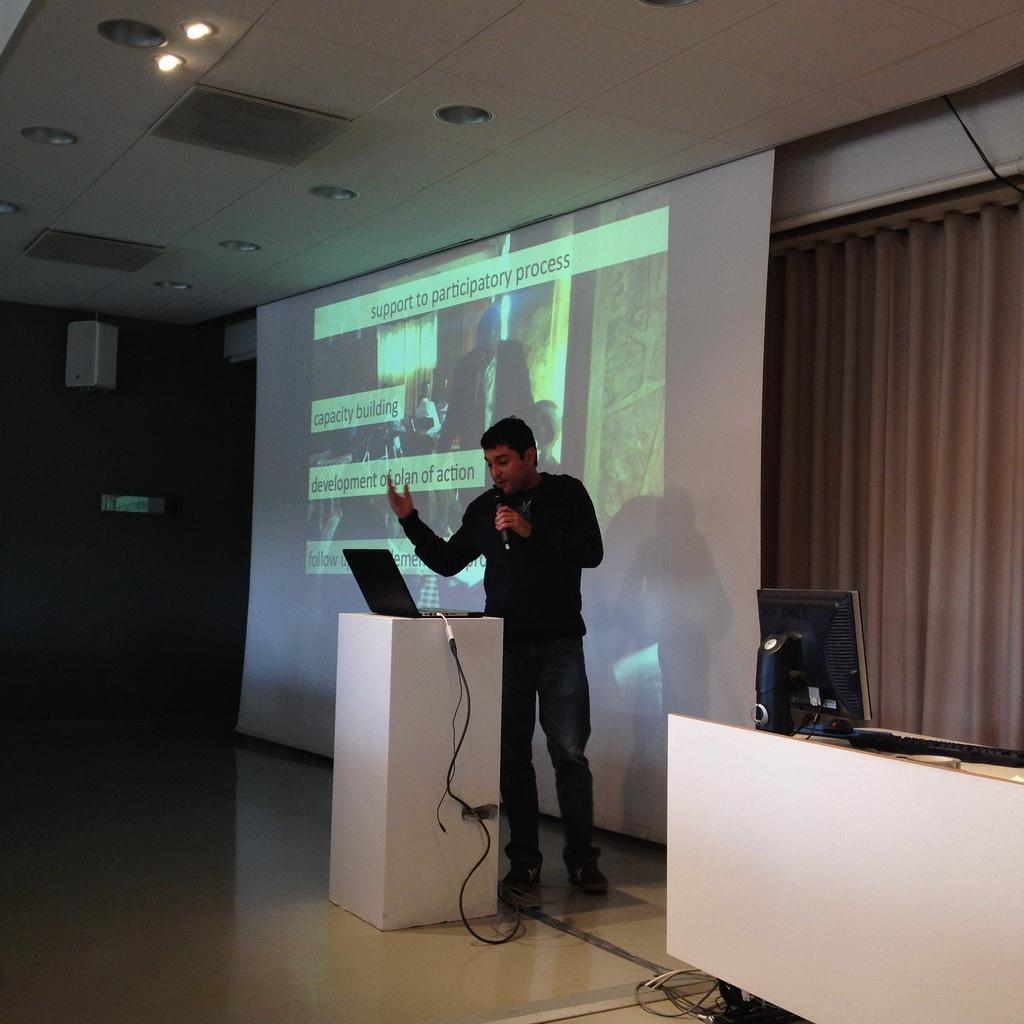<image>
Create a compact narrative representing the image presented. A man is giving a lecture with a screen behind him showing participatory process. 